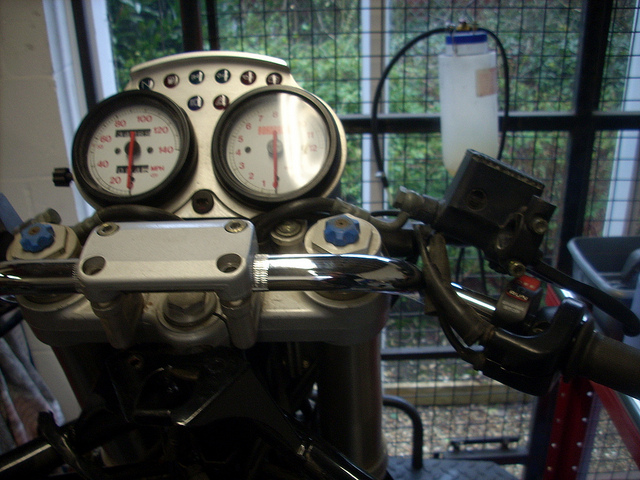<image>What vehicle is this? I am not sure what the vehicle is. It can be a motorcycle or a moped. What vehicle is this? The vehicle in the image is a motorcycle. 